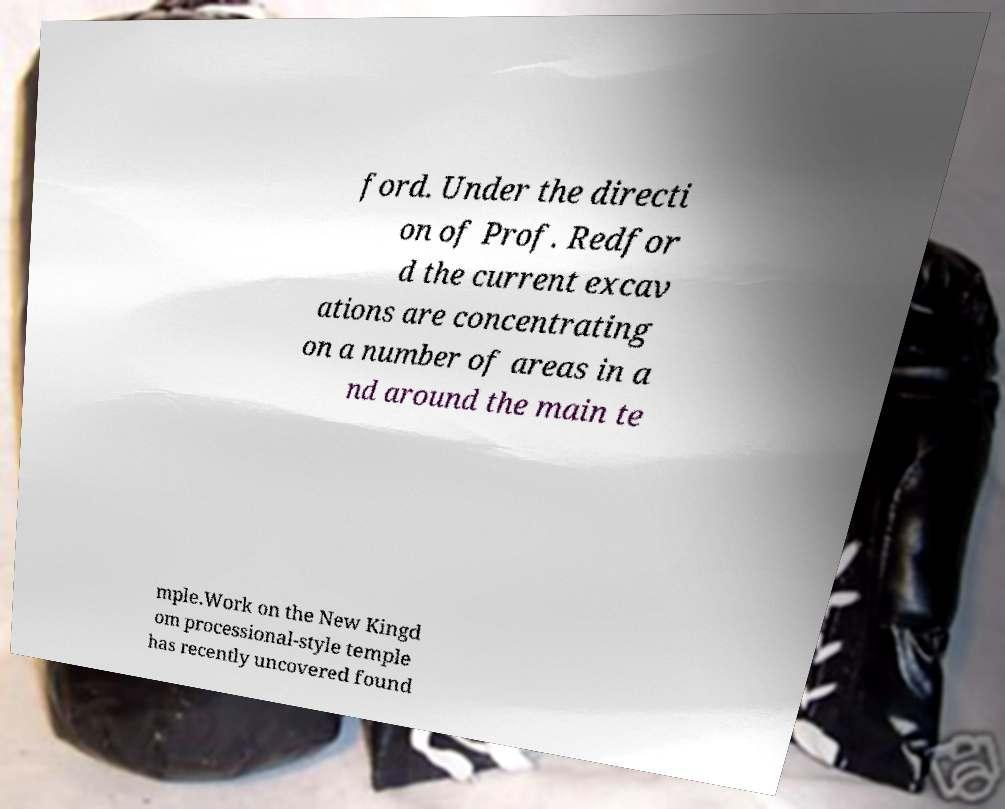Could you extract and type out the text from this image? ford. Under the directi on of Prof. Redfor d the current excav ations are concentrating on a number of areas in a nd around the main te mple.Work on the New Kingd om processional-style temple has recently uncovered found 